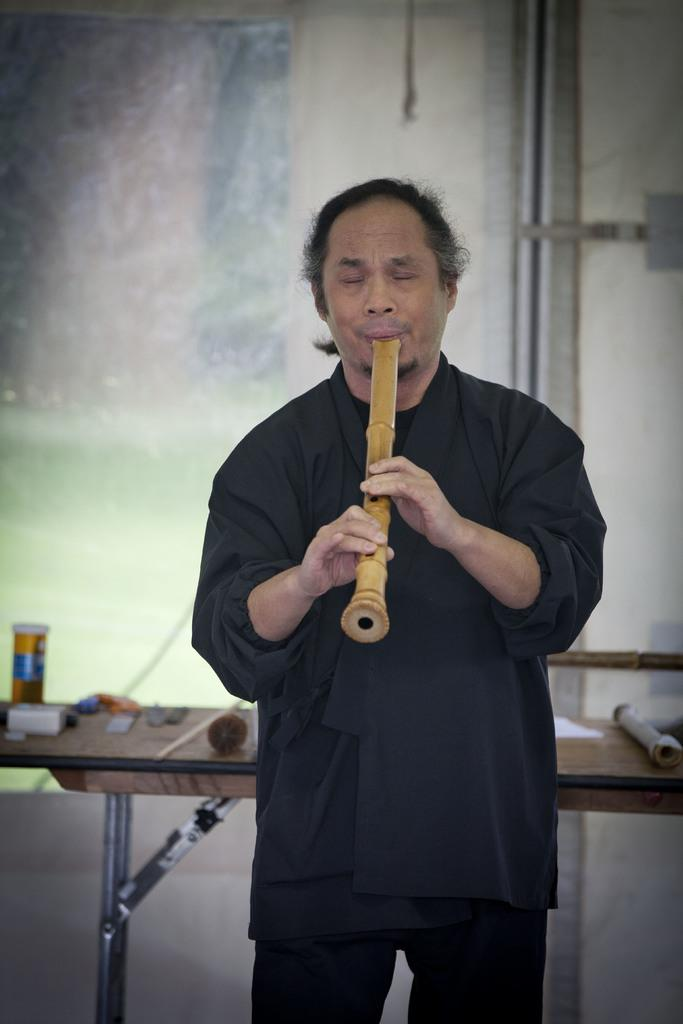Who is the main subject in the image? There is a man in the image. What is the man doing in the image? The man is playing a musical instrument. What piece of furniture is present in the image? There is a table in the image. What is the object on the table in the image? There is an object pressing on the table. What type of vacation is the man planning after finishing his musical performance in the image? There is no information about a vacation or any plans after the musical performance in the image. 